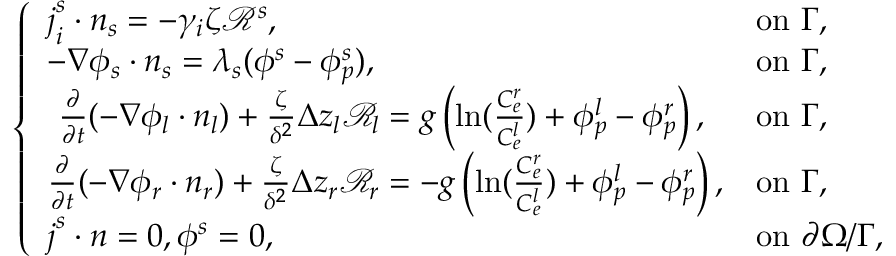Convert formula to latex. <formula><loc_0><loc_0><loc_500><loc_500>\left \{ \begin{array} { l l } { j _ { i } ^ { s } \cdot n _ { s } = - \gamma _ { i } \zeta \mathcal { R } ^ { s } , } & { o n \Gamma , } \\ { - \nabla \phi _ { s } \cdot n _ { s } = \lambda _ { s } ( \phi ^ { s } - \phi _ { p } ^ { s } ) , } & { o n \Gamma , } \\ { \frac { \partial } { \partial t } ( - \nabla \phi _ { l } \cdot n _ { l } ) + \frac { \zeta } { \delta ^ { 2 } } \Delta z _ { l } \mathcal { R } _ { l } = g \left ( \ln ( \frac { C _ { e } ^ { r } } { C _ { e } ^ { l } } ) + \phi _ { p } ^ { l } - \phi _ { p } ^ { r } \right ) , } & { o n \Gamma , } \\ { \frac { \partial } { \partial t } ( - \nabla \phi _ { r } \cdot n _ { r } ) + \frac { \zeta } { \delta ^ { 2 } } \Delta z _ { r } \mathcal { R } _ { r } = - g \left ( \ln ( \frac { C _ { e } ^ { r } } { C _ { e } ^ { l } } ) + \phi _ { p } ^ { l } - \phi _ { p } ^ { r } \right ) , } & { o n \Gamma , } \\ { j ^ { s } \cdot n = 0 , \phi ^ { s } = 0 , } & { o n \partial \Omega / \Gamma , } \end{array}</formula> 